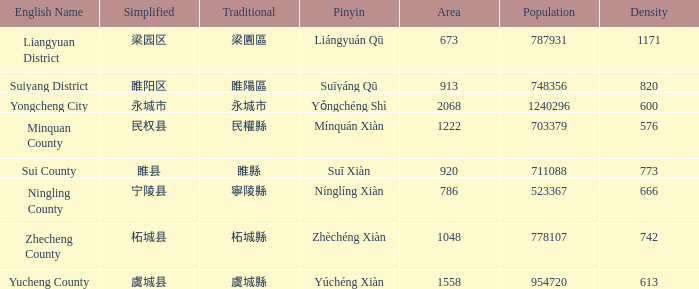How many areas have a population of 703379? 1.0. 